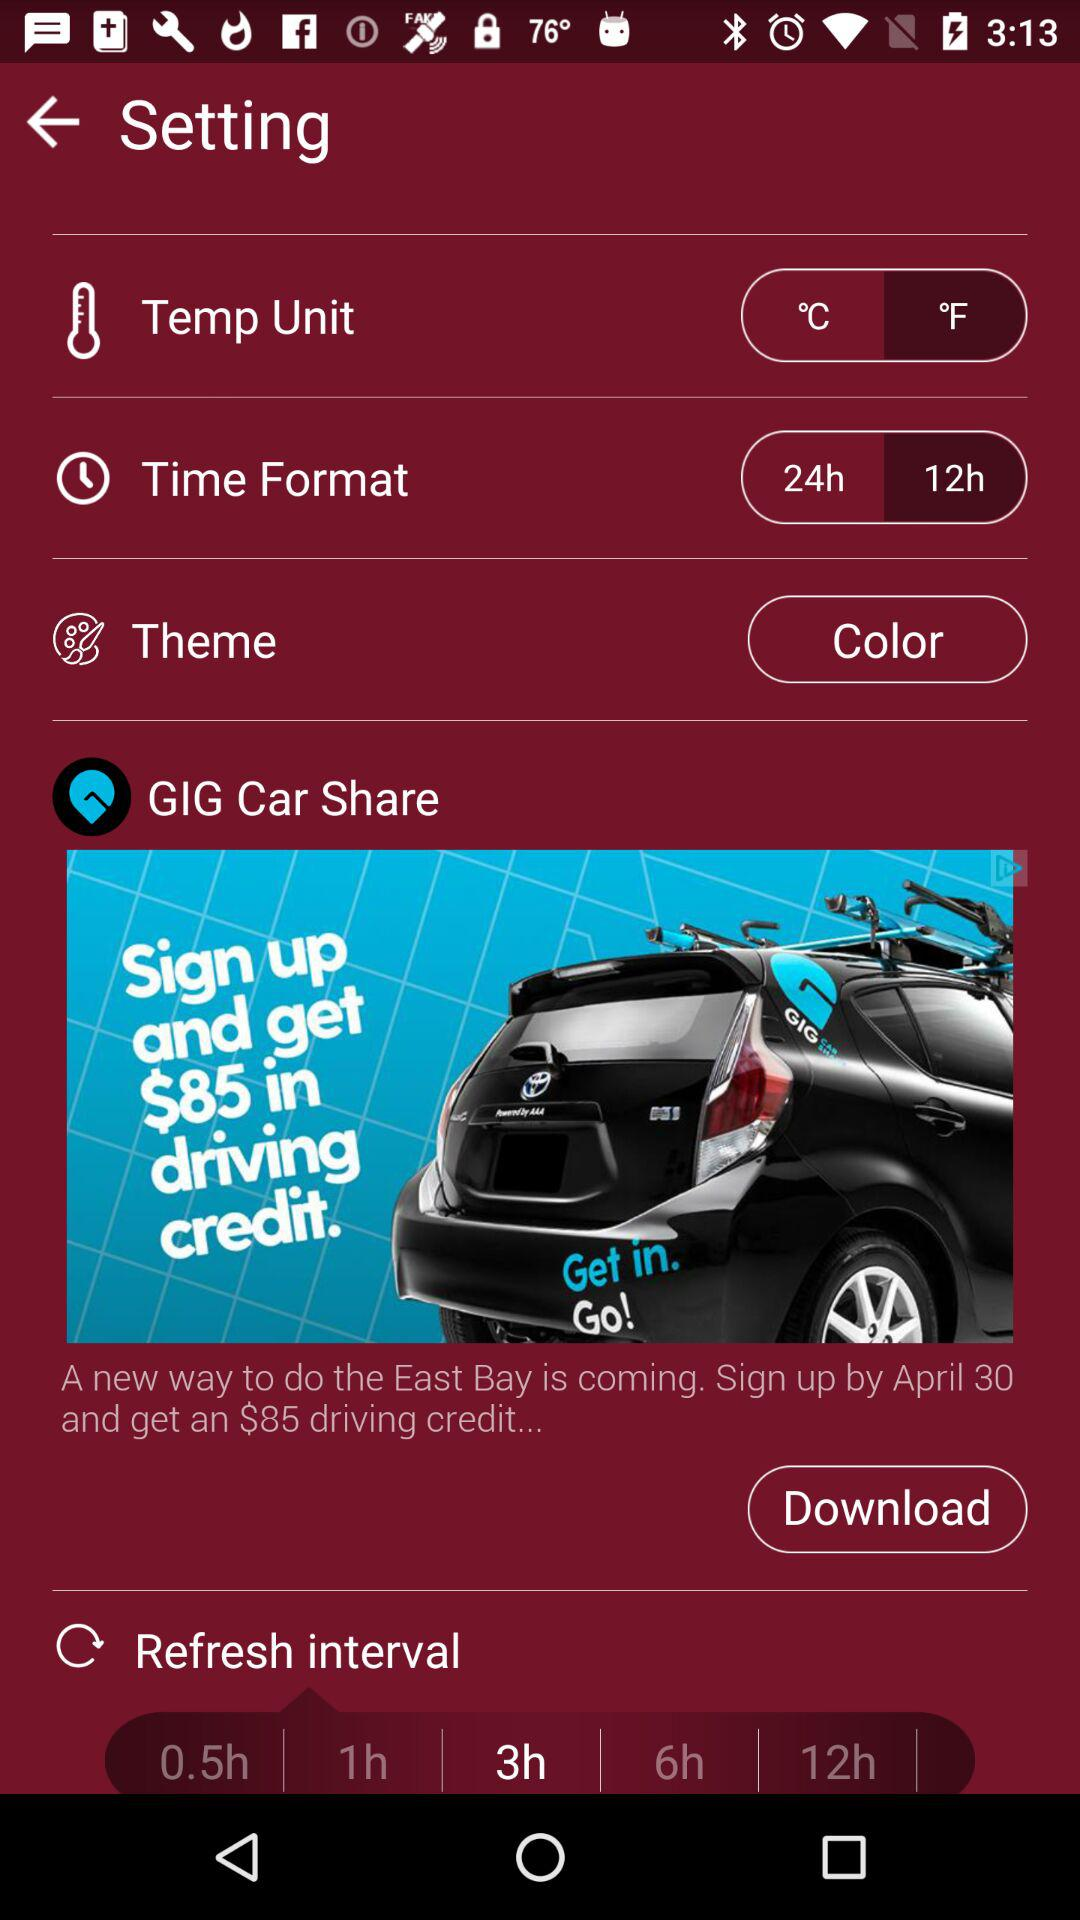Can you explain what the advertisement is promoting, and the offer mentioned? The advertisement in the image is for GIG Car Share, a car-sharing service. They are promoting an offer where new users can sign up by April 30 to receive an $85 credit for driving.  Could you tell me what time it is, according to the phone's display? Based on the phone's display in the image, the time is 3:13. 